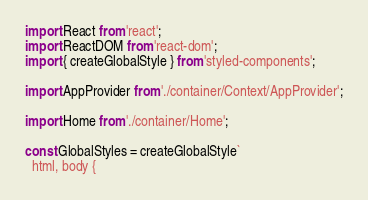<code> <loc_0><loc_0><loc_500><loc_500><_JavaScript_>import React from 'react';
import ReactDOM from 'react-dom';
import { createGlobalStyle } from 'styled-components';

import AppProvider from './container/Context/AppProvider';

import Home from './container/Home';

const GlobalStyles = createGlobalStyle`
  html, body {</code> 